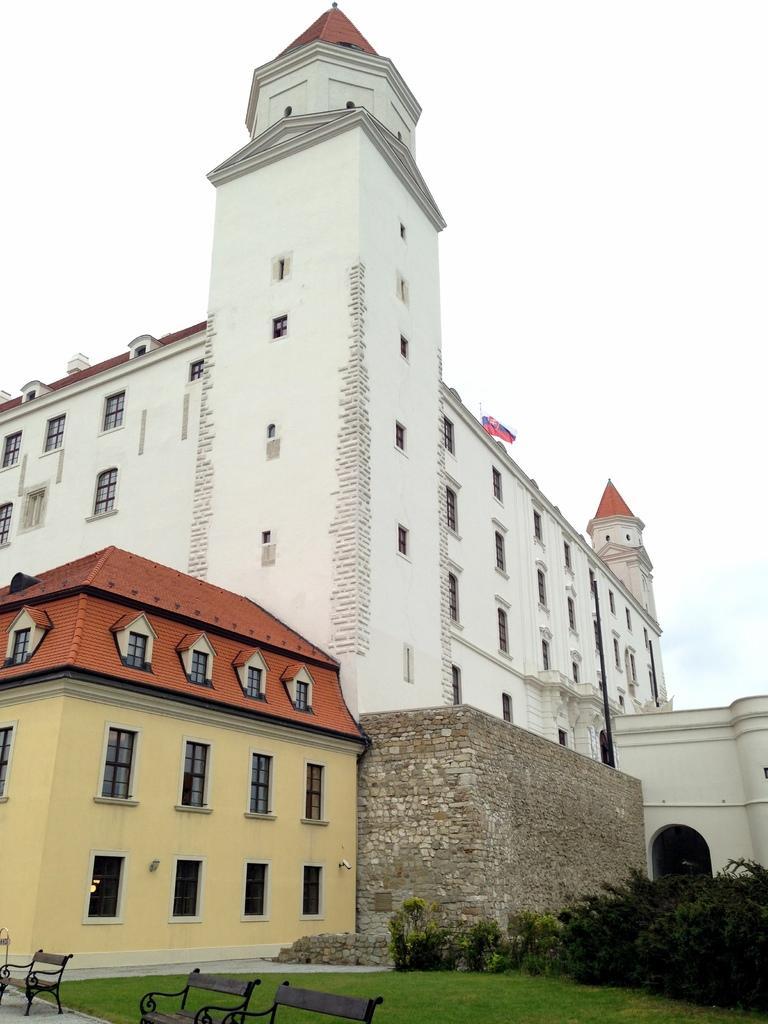Can you describe this image briefly? In this image there are some buildings in the middle of this image. There are some trees in the bottom left corner of this image and there are some tables on the bottom left corner of this image. There is a sky on the top of this image. 